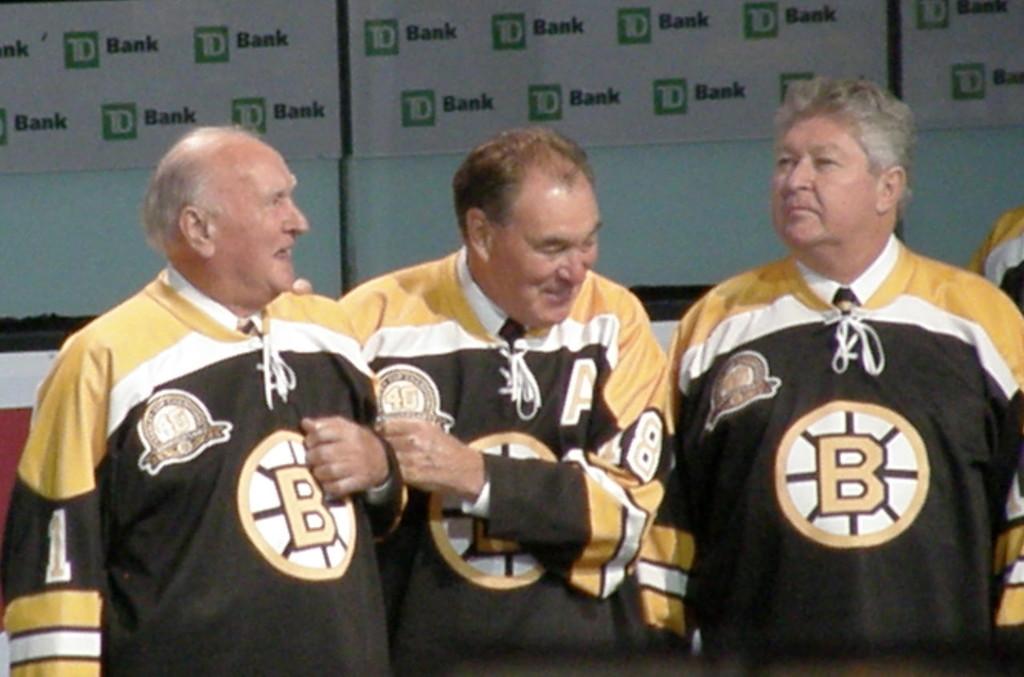What team's jersey are these men wearing?
Keep it short and to the point. B. What is written on the step and repeat banner behind on the men?
Make the answer very short. Td bank. 